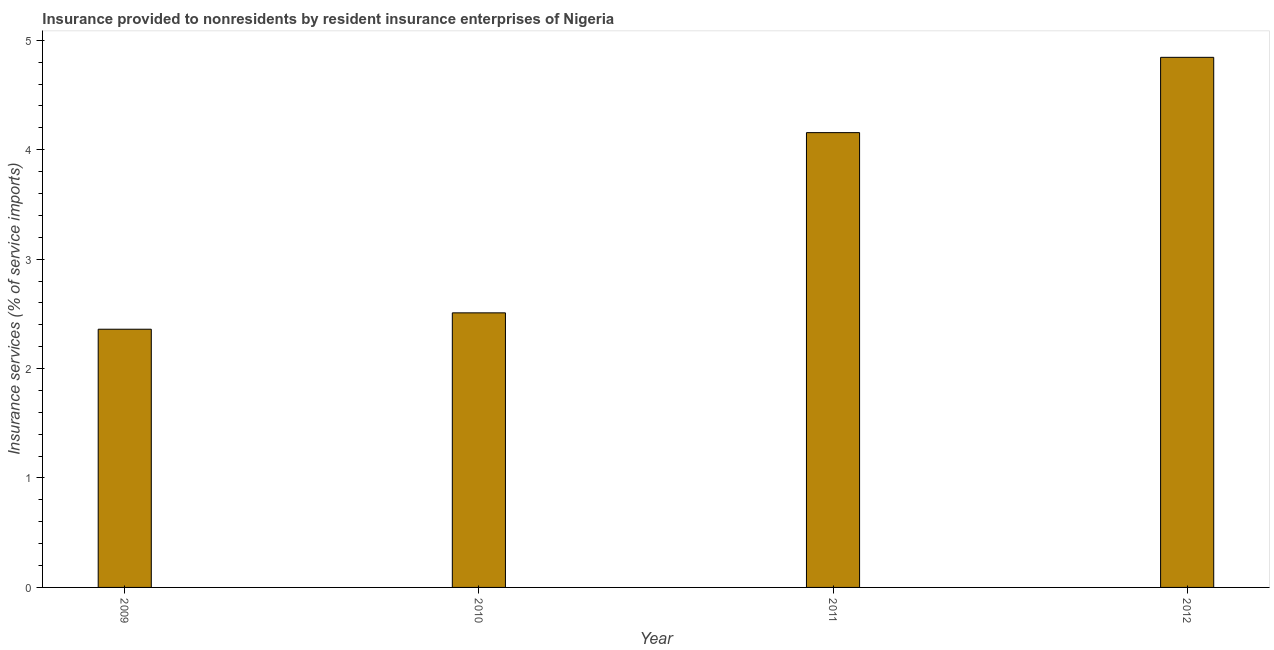Does the graph contain any zero values?
Your answer should be compact. No. Does the graph contain grids?
Offer a very short reply. No. What is the title of the graph?
Ensure brevity in your answer.  Insurance provided to nonresidents by resident insurance enterprises of Nigeria. What is the label or title of the Y-axis?
Offer a very short reply. Insurance services (% of service imports). What is the insurance and financial services in 2011?
Make the answer very short. 4.16. Across all years, what is the maximum insurance and financial services?
Give a very brief answer. 4.84. Across all years, what is the minimum insurance and financial services?
Keep it short and to the point. 2.36. In which year was the insurance and financial services maximum?
Keep it short and to the point. 2012. In which year was the insurance and financial services minimum?
Provide a succinct answer. 2009. What is the sum of the insurance and financial services?
Your answer should be very brief. 13.87. What is the difference between the insurance and financial services in 2010 and 2012?
Your response must be concise. -2.33. What is the average insurance and financial services per year?
Give a very brief answer. 3.47. What is the median insurance and financial services?
Ensure brevity in your answer.  3.33. In how many years, is the insurance and financial services greater than 4.8 %?
Your answer should be very brief. 1. Do a majority of the years between 2010 and 2012 (inclusive) have insurance and financial services greater than 1.8 %?
Your response must be concise. Yes. What is the ratio of the insurance and financial services in 2009 to that in 2012?
Provide a succinct answer. 0.49. Is the difference between the insurance and financial services in 2009 and 2011 greater than the difference between any two years?
Keep it short and to the point. No. What is the difference between the highest and the second highest insurance and financial services?
Give a very brief answer. 0.69. What is the difference between the highest and the lowest insurance and financial services?
Your response must be concise. 2.48. In how many years, is the insurance and financial services greater than the average insurance and financial services taken over all years?
Keep it short and to the point. 2. How many bars are there?
Provide a succinct answer. 4. How many years are there in the graph?
Offer a terse response. 4. Are the values on the major ticks of Y-axis written in scientific E-notation?
Provide a succinct answer. No. What is the Insurance services (% of service imports) of 2009?
Give a very brief answer. 2.36. What is the Insurance services (% of service imports) of 2010?
Your response must be concise. 2.51. What is the Insurance services (% of service imports) of 2011?
Your response must be concise. 4.16. What is the Insurance services (% of service imports) in 2012?
Offer a very short reply. 4.84. What is the difference between the Insurance services (% of service imports) in 2009 and 2010?
Give a very brief answer. -0.15. What is the difference between the Insurance services (% of service imports) in 2009 and 2011?
Your answer should be compact. -1.8. What is the difference between the Insurance services (% of service imports) in 2009 and 2012?
Give a very brief answer. -2.48. What is the difference between the Insurance services (% of service imports) in 2010 and 2011?
Provide a short and direct response. -1.65. What is the difference between the Insurance services (% of service imports) in 2010 and 2012?
Your answer should be very brief. -2.33. What is the difference between the Insurance services (% of service imports) in 2011 and 2012?
Your answer should be very brief. -0.69. What is the ratio of the Insurance services (% of service imports) in 2009 to that in 2010?
Your answer should be compact. 0.94. What is the ratio of the Insurance services (% of service imports) in 2009 to that in 2011?
Provide a succinct answer. 0.57. What is the ratio of the Insurance services (% of service imports) in 2009 to that in 2012?
Provide a succinct answer. 0.49. What is the ratio of the Insurance services (% of service imports) in 2010 to that in 2011?
Make the answer very short. 0.6. What is the ratio of the Insurance services (% of service imports) in 2010 to that in 2012?
Offer a terse response. 0.52. What is the ratio of the Insurance services (% of service imports) in 2011 to that in 2012?
Provide a short and direct response. 0.86. 